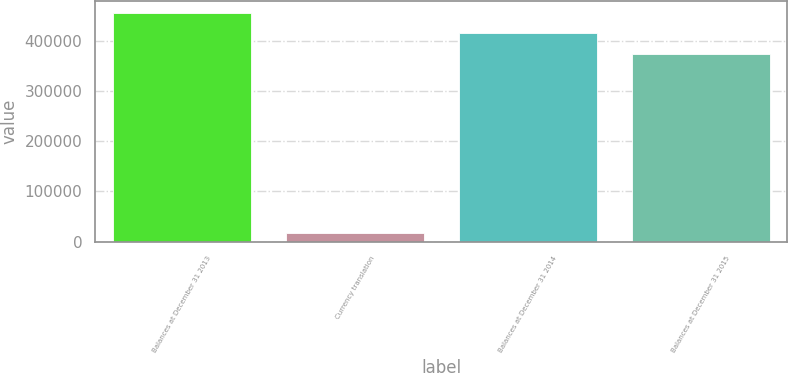Convert chart. <chart><loc_0><loc_0><loc_500><loc_500><bar_chart><fcel>Balances at December 31 2013<fcel>Currency translation<fcel>Balances at December 31 2014<fcel>Balances at December 31 2015<nl><fcel>455826<fcel>16537<fcel>414929<fcel>374033<nl></chart> 